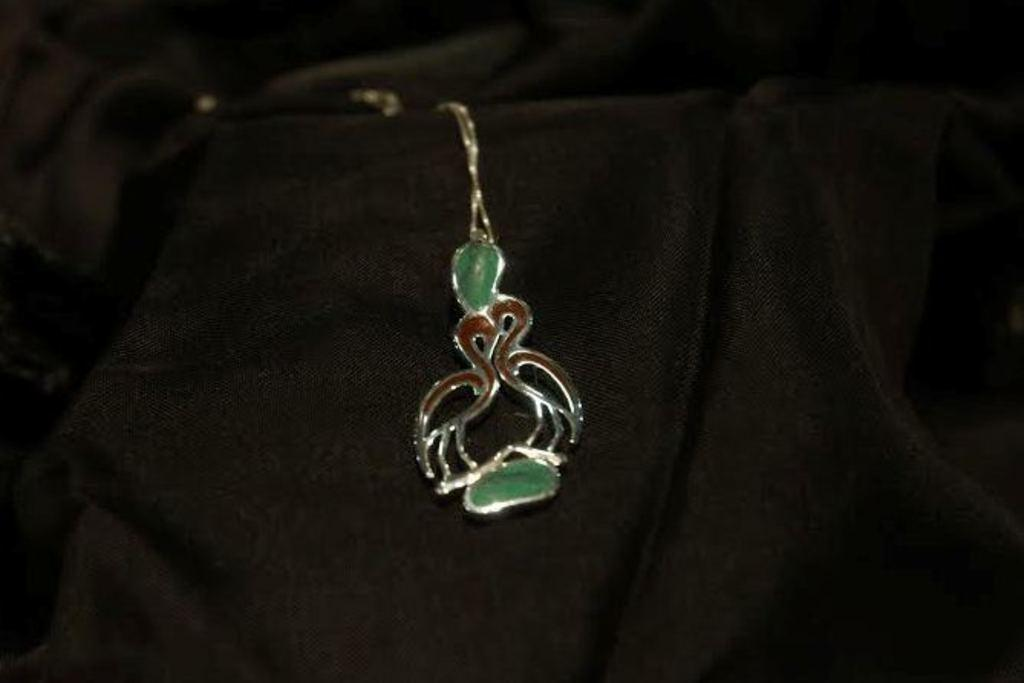What type of object is present in the image? There is a metal object in the image. What can be observed about the background of the image? The background of the image is dark. What type of jail can be seen in the image? There is no jail present in the image; it only features a metal object and a dark background. How many people are crying in the image? There are no people present in the image, so it is not possible to determine if anyone is crying. 